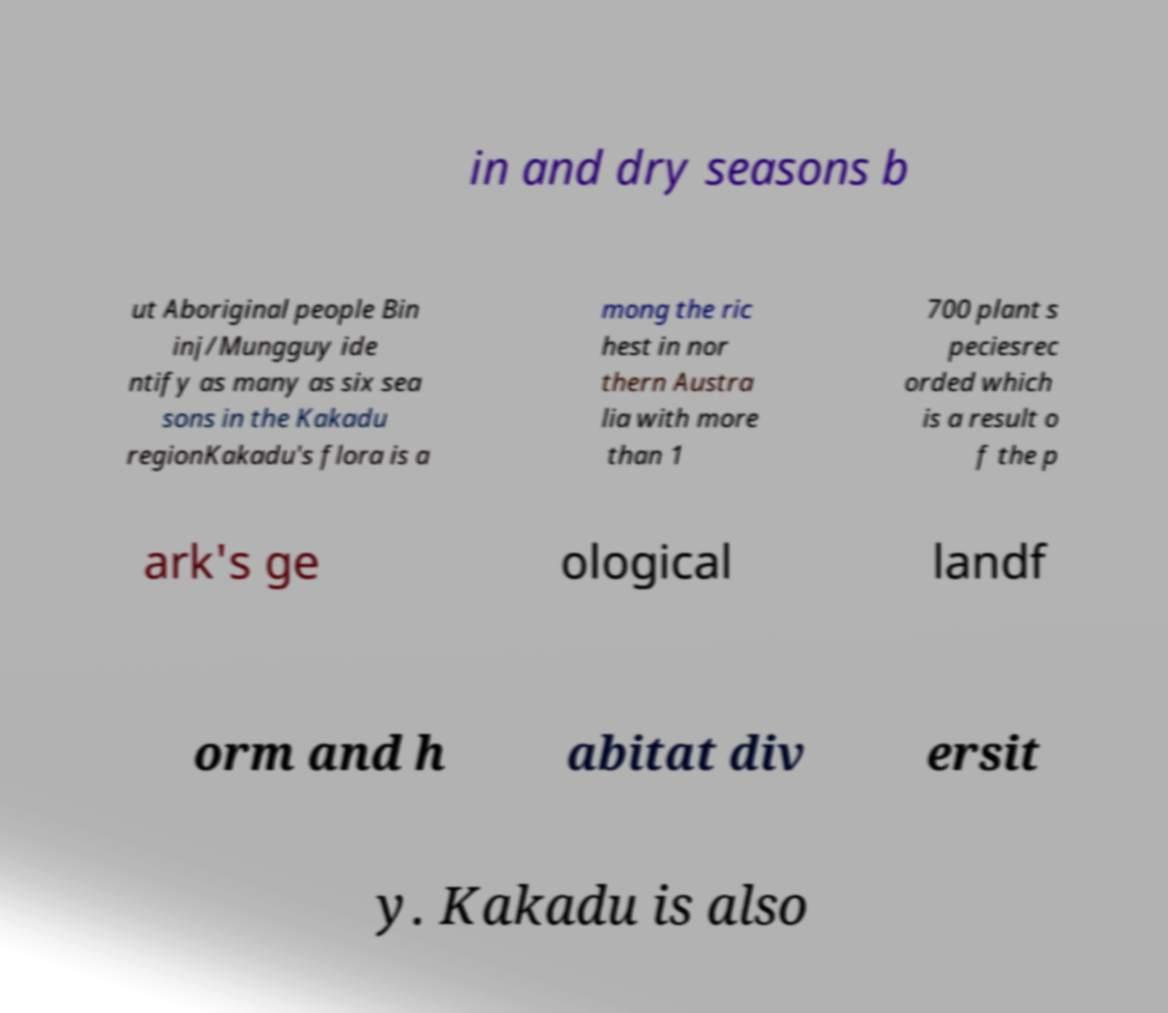Could you extract and type out the text from this image? in and dry seasons b ut Aboriginal people Bin inj/Mungguy ide ntify as many as six sea sons in the Kakadu regionKakadu's flora is a mong the ric hest in nor thern Austra lia with more than 1 700 plant s peciesrec orded which is a result o f the p ark's ge ological landf orm and h abitat div ersit y. Kakadu is also 